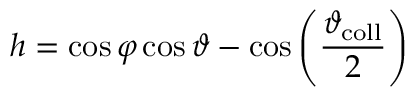<formula> <loc_0><loc_0><loc_500><loc_500>h = \cos { \varphi } \cos { \vartheta } - \cos \left ( \frac { \vartheta _ { c o l l } } { 2 } \right )</formula> 